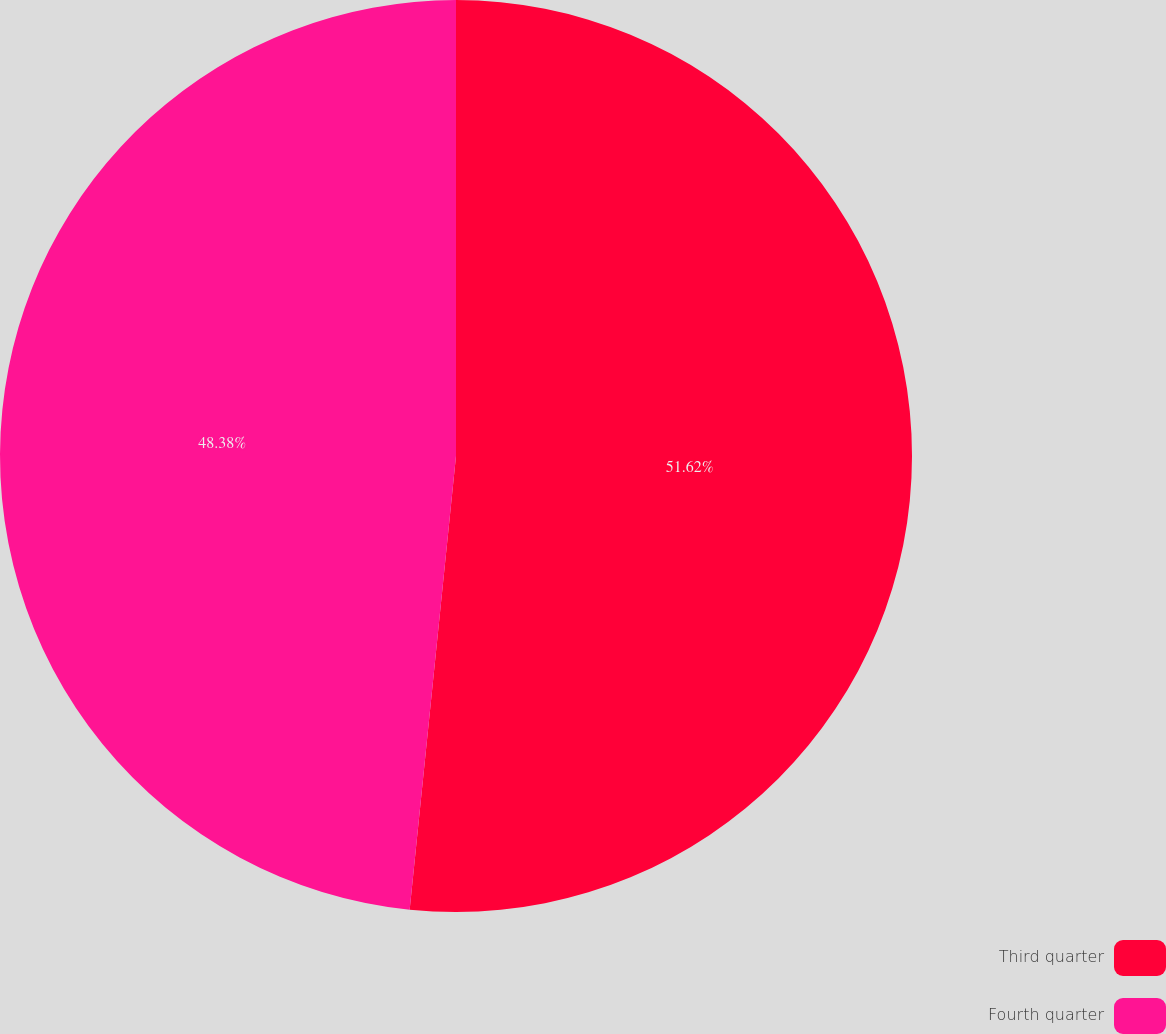<chart> <loc_0><loc_0><loc_500><loc_500><pie_chart><fcel>Third quarter<fcel>Fourth quarter<nl><fcel>51.62%<fcel>48.38%<nl></chart> 